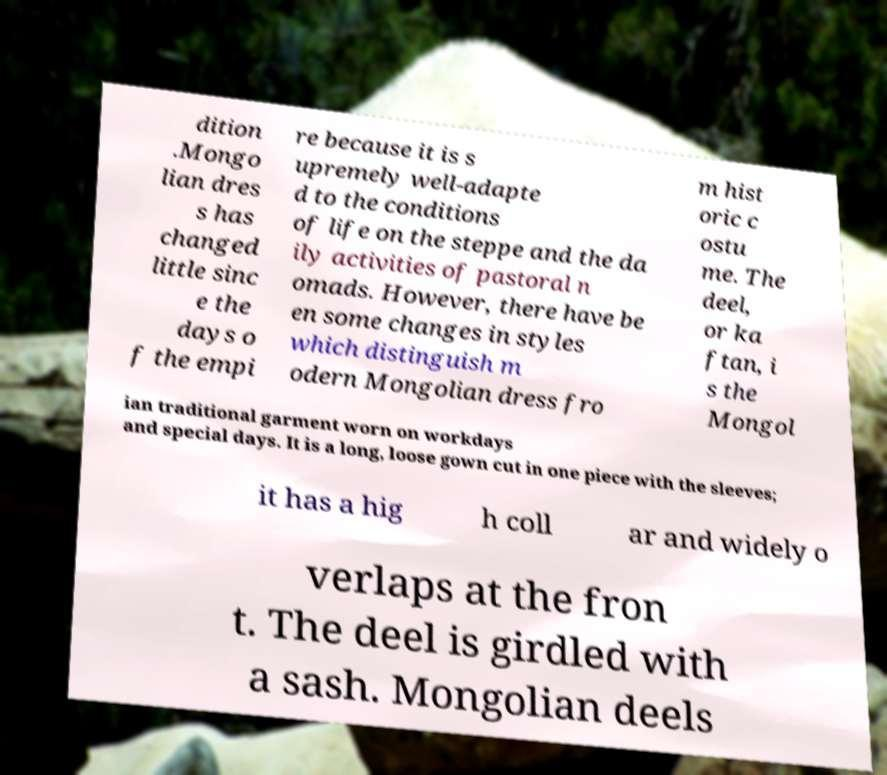Can you accurately transcribe the text from the provided image for me? dition .Mongo lian dres s has changed little sinc e the days o f the empi re because it is s upremely well-adapte d to the conditions of life on the steppe and the da ily activities of pastoral n omads. However, there have be en some changes in styles which distinguish m odern Mongolian dress fro m hist oric c ostu me. The deel, or ka ftan, i s the Mongol ian traditional garment worn on workdays and special days. It is a long, loose gown cut in one piece with the sleeves; it has a hig h coll ar and widely o verlaps at the fron t. The deel is girdled with a sash. Mongolian deels 